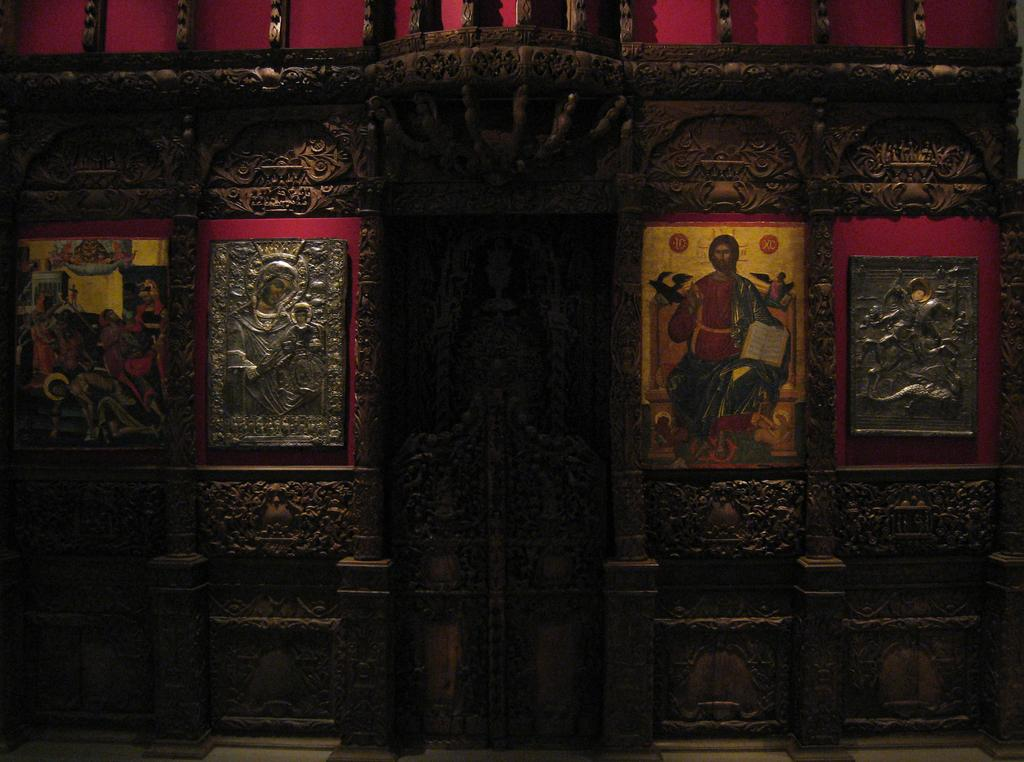What is on the wall in the image? There is a wall with a design in the image. Are there any objects attached to the wall? Yes, there are frames attached to the wall in the image. What type of dress is the wall wearing in the image? The wall is not wearing a dress, as it is an inanimate object and cannot wear clothing. 